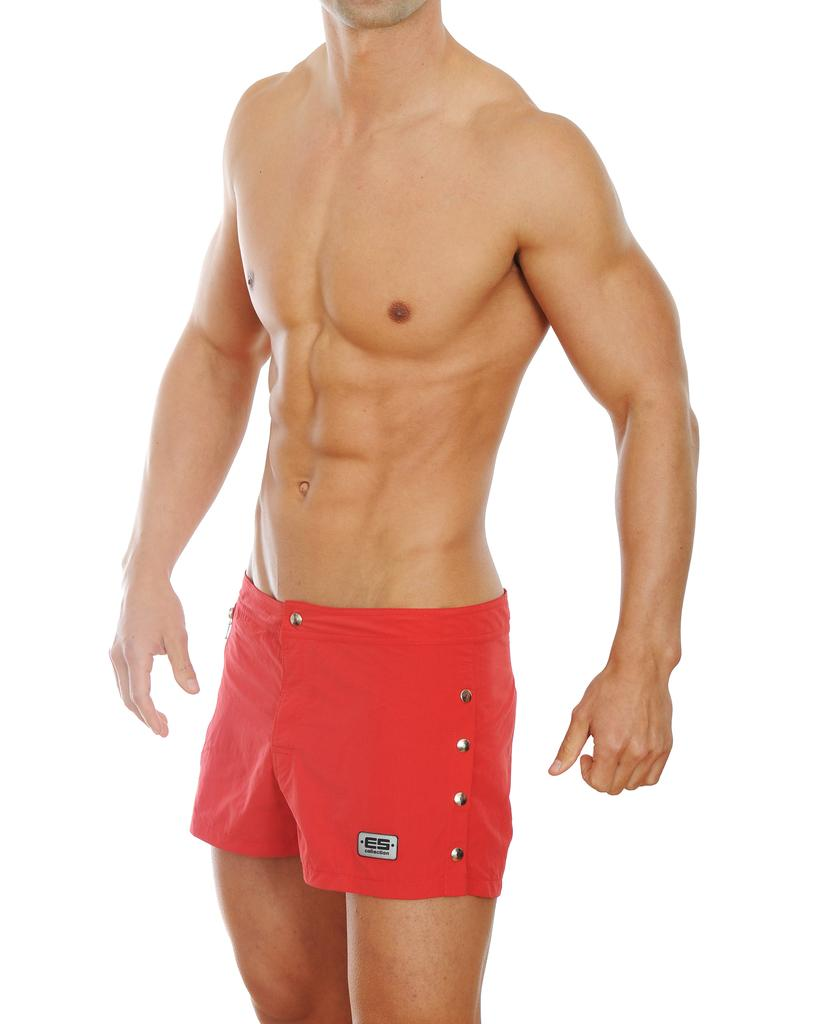What is the main subject of the image? The main subject of the image is a man. What is the man wearing in the image? The man is wearing innerwear on his body. What type of goose can be seen combing its feathers in the image? There is no goose present in the image, and therefore no such activity can be observed. 